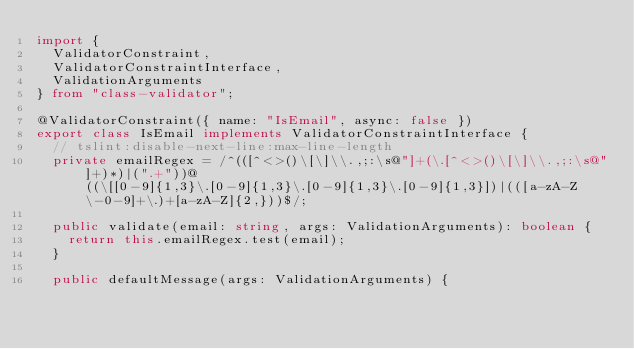Convert code to text. <code><loc_0><loc_0><loc_500><loc_500><_TypeScript_>import {
  ValidatorConstraint,
  ValidatorConstraintInterface,
  ValidationArguments
} from "class-validator";

@ValidatorConstraint({ name: "IsEmail", async: false })
export class IsEmail implements ValidatorConstraintInterface {
  // tslint:disable-next-line:max-line-length
  private emailRegex = /^(([^<>()\[\]\\.,;:\s@"]+(\.[^<>()\[\]\\.,;:\s@"]+)*)|(".+"))@((\[[0-9]{1,3}\.[0-9]{1,3}\.[0-9]{1,3}\.[0-9]{1,3}])|(([a-zA-Z\-0-9]+\.)+[a-zA-Z]{2,}))$/;

  public validate(email: string, args: ValidationArguments): boolean {
    return this.emailRegex.test(email);
  }

  public defaultMessage(args: ValidationArguments) {</code> 